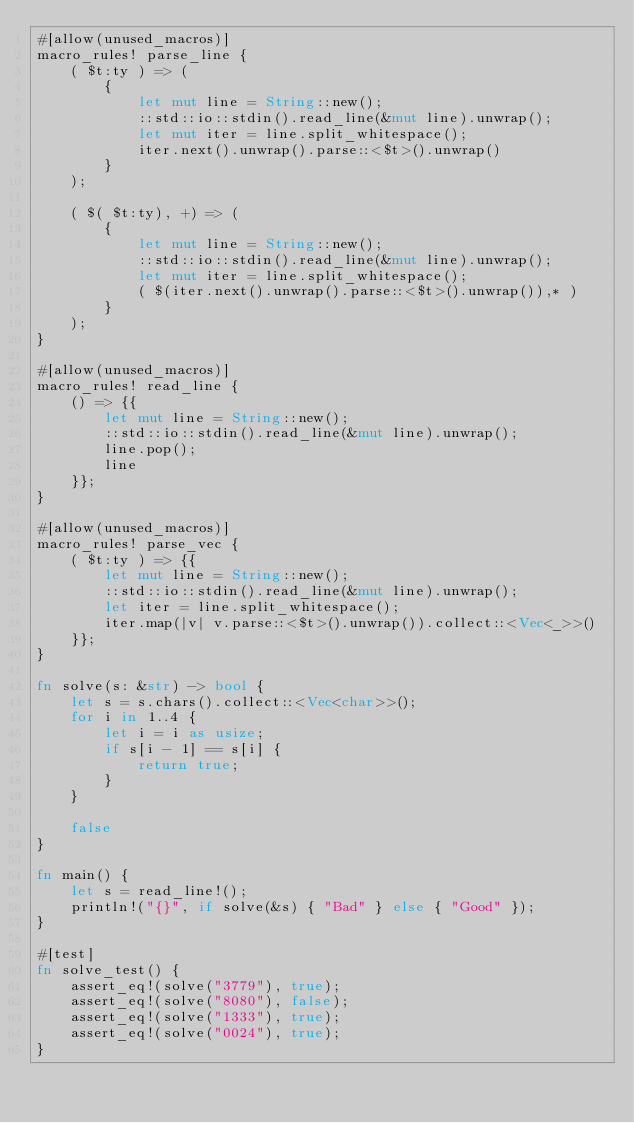Convert code to text. <code><loc_0><loc_0><loc_500><loc_500><_Rust_>#[allow(unused_macros)]
macro_rules! parse_line {
    ( $t:ty ) => (
        {
            let mut line = String::new();
            ::std::io::stdin().read_line(&mut line).unwrap();
            let mut iter = line.split_whitespace();
            iter.next().unwrap().parse::<$t>().unwrap()
        }
    );

    ( $( $t:ty), +) => (
        {
            let mut line = String::new();
            ::std::io::stdin().read_line(&mut line).unwrap();
            let mut iter = line.split_whitespace();
            ( $(iter.next().unwrap().parse::<$t>().unwrap()),* )
        }
    );
}

#[allow(unused_macros)]
macro_rules! read_line {
    () => {{
        let mut line = String::new();
        ::std::io::stdin().read_line(&mut line).unwrap();
        line.pop();
        line
    }};
}

#[allow(unused_macros)]
macro_rules! parse_vec {
    ( $t:ty ) => {{
        let mut line = String::new();
        ::std::io::stdin().read_line(&mut line).unwrap();
        let iter = line.split_whitespace();
        iter.map(|v| v.parse::<$t>().unwrap()).collect::<Vec<_>>()
    }};
}

fn solve(s: &str) -> bool {
    let s = s.chars().collect::<Vec<char>>();
    for i in 1..4 {
        let i = i as usize;
        if s[i - 1] == s[i] {
            return true;
        }
    }

    false
}

fn main() {
    let s = read_line!();
    println!("{}", if solve(&s) { "Bad" } else { "Good" });
}

#[test]
fn solve_test() {
    assert_eq!(solve("3779"), true);
    assert_eq!(solve("8080"), false);
    assert_eq!(solve("1333"), true);
    assert_eq!(solve("0024"), true);
}
</code> 